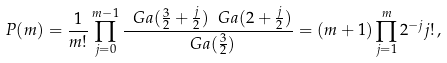<formula> <loc_0><loc_0><loc_500><loc_500>P ( m ) = \frac { 1 } { m ! } \prod _ { j = 0 } ^ { m - 1 } \frac { \ G a ( \frac { 3 } { 2 } + \frac { j } { 2 } ) \ G a ( 2 + \frac { j } { 2 } ) } { \ G a ( \frac { 3 } { 2 } ) } = ( m + 1 ) \prod _ { j = 1 } ^ { m } 2 ^ { - j } j ! \, ,</formula> 